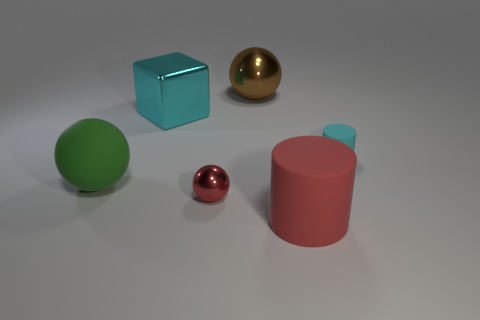Add 3 big brown balls. How many objects exist? 9 Subtract all cylinders. How many objects are left? 4 Subtract all cylinders. Subtract all tiny cylinders. How many objects are left? 3 Add 2 brown objects. How many brown objects are left? 3 Add 1 large shiny objects. How many large shiny objects exist? 3 Subtract 0 purple spheres. How many objects are left? 6 